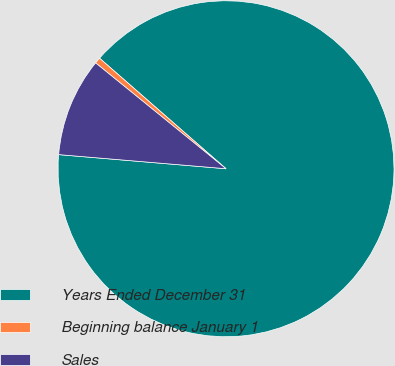Convert chart. <chart><loc_0><loc_0><loc_500><loc_500><pie_chart><fcel>Years Ended December 31<fcel>Beginning balance January 1<fcel>Sales<nl><fcel>89.91%<fcel>0.58%<fcel>9.51%<nl></chart> 